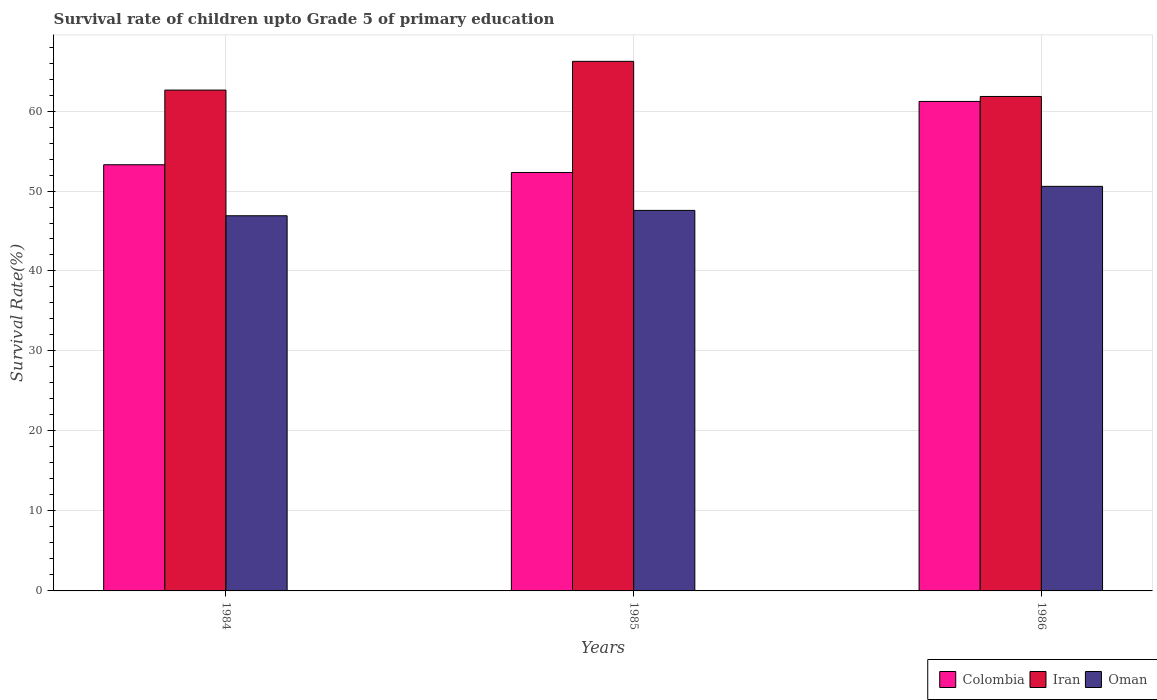Are the number of bars per tick equal to the number of legend labels?
Your response must be concise. Yes. Are the number of bars on each tick of the X-axis equal?
Offer a very short reply. Yes. In how many cases, is the number of bars for a given year not equal to the number of legend labels?
Ensure brevity in your answer.  0. What is the survival rate of children in Oman in 1984?
Provide a short and direct response. 46.91. Across all years, what is the maximum survival rate of children in Oman?
Your answer should be compact. 50.58. Across all years, what is the minimum survival rate of children in Iran?
Provide a short and direct response. 61.82. In which year was the survival rate of children in Oman maximum?
Make the answer very short. 1986. In which year was the survival rate of children in Iran minimum?
Give a very brief answer. 1986. What is the total survival rate of children in Iran in the graph?
Your response must be concise. 190.65. What is the difference between the survival rate of children in Oman in 1984 and that in 1985?
Your response must be concise. -0.67. What is the difference between the survival rate of children in Iran in 1986 and the survival rate of children in Oman in 1985?
Provide a short and direct response. 14.25. What is the average survival rate of children in Oman per year?
Make the answer very short. 48.35. In the year 1986, what is the difference between the survival rate of children in Oman and survival rate of children in Colombia?
Your response must be concise. -10.62. In how many years, is the survival rate of children in Colombia greater than 22 %?
Your response must be concise. 3. What is the ratio of the survival rate of children in Iran in 1984 to that in 1986?
Provide a short and direct response. 1.01. Is the survival rate of children in Oman in 1984 less than that in 1986?
Your answer should be very brief. Yes. Is the difference between the survival rate of children in Oman in 1984 and 1985 greater than the difference between the survival rate of children in Colombia in 1984 and 1985?
Provide a short and direct response. No. What is the difference between the highest and the second highest survival rate of children in Iran?
Make the answer very short. 3.59. What is the difference between the highest and the lowest survival rate of children in Colombia?
Ensure brevity in your answer.  8.88. In how many years, is the survival rate of children in Oman greater than the average survival rate of children in Oman taken over all years?
Offer a terse response. 1. What does the 3rd bar from the left in 1984 represents?
Your answer should be compact. Oman. What does the 2nd bar from the right in 1984 represents?
Offer a terse response. Iran. How many bars are there?
Make the answer very short. 9. Are all the bars in the graph horizontal?
Provide a short and direct response. No. Does the graph contain any zero values?
Give a very brief answer. No. Does the graph contain grids?
Give a very brief answer. Yes. How many legend labels are there?
Provide a succinct answer. 3. How are the legend labels stacked?
Give a very brief answer. Horizontal. What is the title of the graph?
Your answer should be compact. Survival rate of children upto Grade 5 of primary education. What is the label or title of the X-axis?
Provide a short and direct response. Years. What is the label or title of the Y-axis?
Give a very brief answer. Survival Rate(%). What is the Survival Rate(%) of Colombia in 1984?
Your response must be concise. 53.28. What is the Survival Rate(%) in Iran in 1984?
Offer a very short reply. 62.62. What is the Survival Rate(%) of Oman in 1984?
Offer a very short reply. 46.91. What is the Survival Rate(%) in Colombia in 1985?
Your response must be concise. 52.32. What is the Survival Rate(%) of Iran in 1985?
Your response must be concise. 66.21. What is the Survival Rate(%) in Oman in 1985?
Your response must be concise. 47.58. What is the Survival Rate(%) in Colombia in 1986?
Offer a terse response. 61.2. What is the Survival Rate(%) in Iran in 1986?
Provide a short and direct response. 61.82. What is the Survival Rate(%) of Oman in 1986?
Give a very brief answer. 50.58. Across all years, what is the maximum Survival Rate(%) of Colombia?
Your response must be concise. 61.2. Across all years, what is the maximum Survival Rate(%) of Iran?
Keep it short and to the point. 66.21. Across all years, what is the maximum Survival Rate(%) of Oman?
Offer a terse response. 50.58. Across all years, what is the minimum Survival Rate(%) of Colombia?
Offer a very short reply. 52.32. Across all years, what is the minimum Survival Rate(%) in Iran?
Provide a succinct answer. 61.82. Across all years, what is the minimum Survival Rate(%) in Oman?
Your answer should be compact. 46.91. What is the total Survival Rate(%) in Colombia in the graph?
Offer a terse response. 166.8. What is the total Survival Rate(%) of Iran in the graph?
Ensure brevity in your answer.  190.65. What is the total Survival Rate(%) in Oman in the graph?
Your response must be concise. 145.06. What is the difference between the Survival Rate(%) in Colombia in 1984 and that in 1985?
Your response must be concise. 0.97. What is the difference between the Survival Rate(%) in Iran in 1984 and that in 1985?
Your answer should be very brief. -3.59. What is the difference between the Survival Rate(%) of Oman in 1984 and that in 1985?
Your response must be concise. -0.67. What is the difference between the Survival Rate(%) in Colombia in 1984 and that in 1986?
Give a very brief answer. -7.92. What is the difference between the Survival Rate(%) of Iran in 1984 and that in 1986?
Keep it short and to the point. 0.8. What is the difference between the Survival Rate(%) of Oman in 1984 and that in 1986?
Offer a very short reply. -3.68. What is the difference between the Survival Rate(%) in Colombia in 1985 and that in 1986?
Make the answer very short. -8.88. What is the difference between the Survival Rate(%) in Iran in 1985 and that in 1986?
Your answer should be compact. 4.39. What is the difference between the Survival Rate(%) in Oman in 1985 and that in 1986?
Provide a succinct answer. -3.01. What is the difference between the Survival Rate(%) in Colombia in 1984 and the Survival Rate(%) in Iran in 1985?
Offer a terse response. -12.93. What is the difference between the Survival Rate(%) in Colombia in 1984 and the Survival Rate(%) in Oman in 1985?
Ensure brevity in your answer.  5.71. What is the difference between the Survival Rate(%) in Iran in 1984 and the Survival Rate(%) in Oman in 1985?
Provide a short and direct response. 15.04. What is the difference between the Survival Rate(%) in Colombia in 1984 and the Survival Rate(%) in Iran in 1986?
Provide a succinct answer. -8.54. What is the difference between the Survival Rate(%) in Colombia in 1984 and the Survival Rate(%) in Oman in 1986?
Provide a short and direct response. 2.7. What is the difference between the Survival Rate(%) in Iran in 1984 and the Survival Rate(%) in Oman in 1986?
Provide a short and direct response. 12.04. What is the difference between the Survival Rate(%) in Colombia in 1985 and the Survival Rate(%) in Iran in 1986?
Your response must be concise. -9.5. What is the difference between the Survival Rate(%) of Colombia in 1985 and the Survival Rate(%) of Oman in 1986?
Make the answer very short. 1.74. What is the difference between the Survival Rate(%) of Iran in 1985 and the Survival Rate(%) of Oman in 1986?
Your answer should be compact. 15.63. What is the average Survival Rate(%) in Colombia per year?
Offer a very short reply. 55.6. What is the average Survival Rate(%) in Iran per year?
Give a very brief answer. 63.55. What is the average Survival Rate(%) in Oman per year?
Offer a terse response. 48.35. In the year 1984, what is the difference between the Survival Rate(%) of Colombia and Survival Rate(%) of Iran?
Keep it short and to the point. -9.33. In the year 1984, what is the difference between the Survival Rate(%) of Colombia and Survival Rate(%) of Oman?
Your answer should be very brief. 6.38. In the year 1984, what is the difference between the Survival Rate(%) in Iran and Survival Rate(%) in Oman?
Keep it short and to the point. 15.71. In the year 1985, what is the difference between the Survival Rate(%) in Colombia and Survival Rate(%) in Iran?
Provide a succinct answer. -13.89. In the year 1985, what is the difference between the Survival Rate(%) of Colombia and Survival Rate(%) of Oman?
Ensure brevity in your answer.  4.74. In the year 1985, what is the difference between the Survival Rate(%) in Iran and Survival Rate(%) in Oman?
Your response must be concise. 18.63. In the year 1986, what is the difference between the Survival Rate(%) in Colombia and Survival Rate(%) in Iran?
Keep it short and to the point. -0.62. In the year 1986, what is the difference between the Survival Rate(%) in Colombia and Survival Rate(%) in Oman?
Ensure brevity in your answer.  10.62. In the year 1986, what is the difference between the Survival Rate(%) of Iran and Survival Rate(%) of Oman?
Your answer should be very brief. 11.24. What is the ratio of the Survival Rate(%) in Colombia in 1984 to that in 1985?
Keep it short and to the point. 1.02. What is the ratio of the Survival Rate(%) of Iran in 1984 to that in 1985?
Provide a short and direct response. 0.95. What is the ratio of the Survival Rate(%) in Oman in 1984 to that in 1985?
Make the answer very short. 0.99. What is the ratio of the Survival Rate(%) in Colombia in 1984 to that in 1986?
Your answer should be compact. 0.87. What is the ratio of the Survival Rate(%) in Iran in 1984 to that in 1986?
Your answer should be compact. 1.01. What is the ratio of the Survival Rate(%) in Oman in 1984 to that in 1986?
Your answer should be compact. 0.93. What is the ratio of the Survival Rate(%) of Colombia in 1985 to that in 1986?
Your response must be concise. 0.85. What is the ratio of the Survival Rate(%) of Iran in 1985 to that in 1986?
Ensure brevity in your answer.  1.07. What is the ratio of the Survival Rate(%) in Oman in 1985 to that in 1986?
Your answer should be very brief. 0.94. What is the difference between the highest and the second highest Survival Rate(%) in Colombia?
Your response must be concise. 7.92. What is the difference between the highest and the second highest Survival Rate(%) in Iran?
Your answer should be compact. 3.59. What is the difference between the highest and the second highest Survival Rate(%) of Oman?
Your response must be concise. 3.01. What is the difference between the highest and the lowest Survival Rate(%) of Colombia?
Offer a terse response. 8.88. What is the difference between the highest and the lowest Survival Rate(%) of Iran?
Your answer should be very brief. 4.39. What is the difference between the highest and the lowest Survival Rate(%) of Oman?
Offer a very short reply. 3.68. 